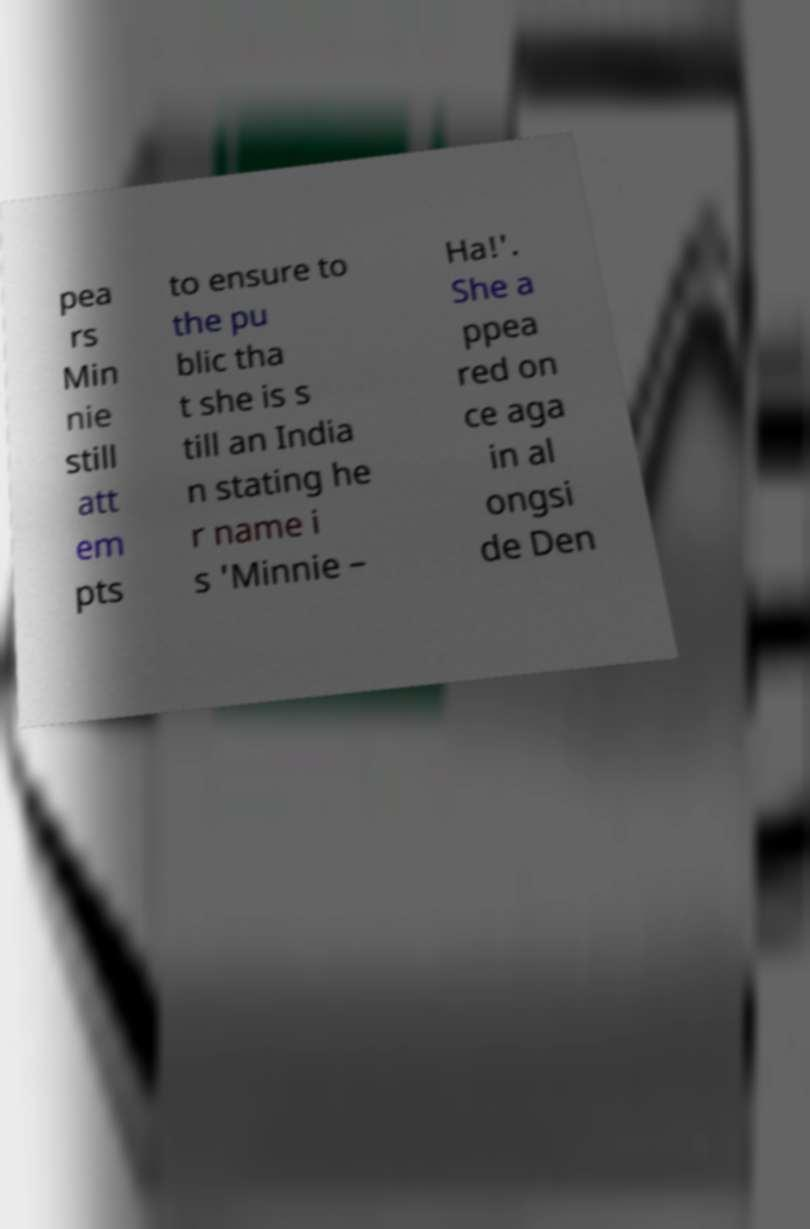Could you extract and type out the text from this image? pea rs Min nie still att em pts to ensure to the pu blic tha t she is s till an India n stating he r name i s 'Minnie – Ha!'. She a ppea red on ce aga in al ongsi de Den 